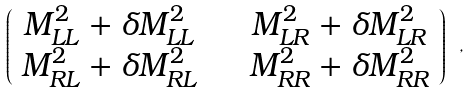<formula> <loc_0><loc_0><loc_500><loc_500>\left ( \begin{array} { c c } M ^ { 2 } _ { L L } + \delta M ^ { 2 } _ { L L } & \quad M ^ { 2 } _ { L R } + \delta M ^ { 2 } _ { L R } \\ M ^ { 2 } _ { R L } + \delta M ^ { 2 } _ { R L } & \quad M ^ { 2 } _ { R R } + \delta M ^ { 2 } _ { R R } \end{array} \right ) \ ,</formula> 